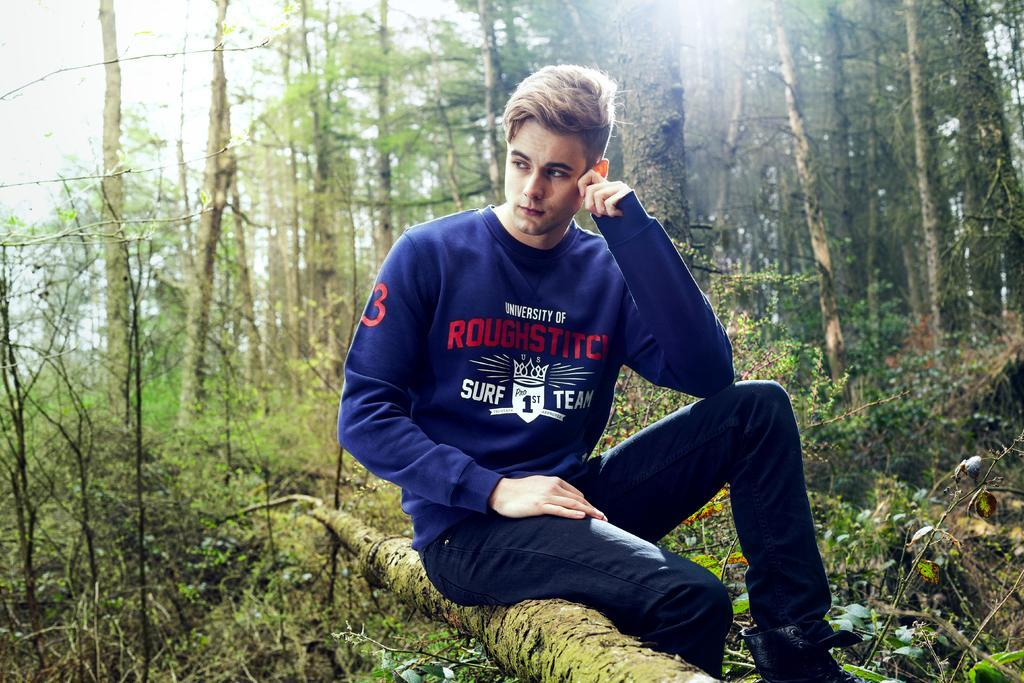What is the man in the image doing? The man is sitting on a wooden log in the image. What type of natural elements can be seen in the image? There are plants and a group of trees visible in the image. What part of the trees can be seen in the image? The bark of the trees is visible in the image. What is visible in the background of the image? The sky is visible in the image. How does the man sort the plants in the image? There is no indication in the image that the man is sorting plants, as he is simply sitting on a wooden log. 